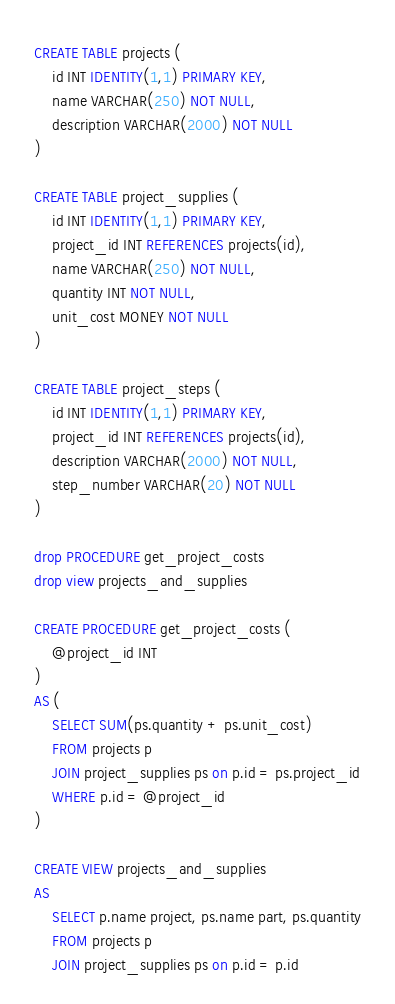<code> <loc_0><loc_0><loc_500><loc_500><_SQL_>CREATE TABLE projects (
    id INT IDENTITY(1,1) PRIMARY KEY,
    name VARCHAR(250) NOT NULL,
    description VARCHAR(2000) NOT NULL
)

CREATE TABLE project_supplies (
    id INT IDENTITY(1,1) PRIMARY KEY,
    project_id INT REFERENCES projects(id),
    name VARCHAR(250) NOT NULL,
    quantity INT NOT NULL,
    unit_cost MONEY NOT NULL
)

CREATE TABLE project_steps (
    id INT IDENTITY(1,1) PRIMARY KEY,
    project_id INT REFERENCES projects(id),
    description VARCHAR(2000) NOT NULL,
    step_number VARCHAR(20) NOT NULL
)

drop PROCEDURE get_project_costs
drop view projects_and_supplies

CREATE PROCEDURE get_project_costs (
    @project_id INT
)
AS (
    SELECT SUM(ps.quantity + ps.unit_cost)
    FROM projects p
    JOIN project_supplies ps on p.id = ps.project_id
    WHERE p.id = @project_id
)

CREATE VIEW projects_and_supplies
AS
    SELECT p.name project, ps.name part, ps.quantity
    FROM projects p
    JOIN project_supplies ps on p.id = p.id


</code> 